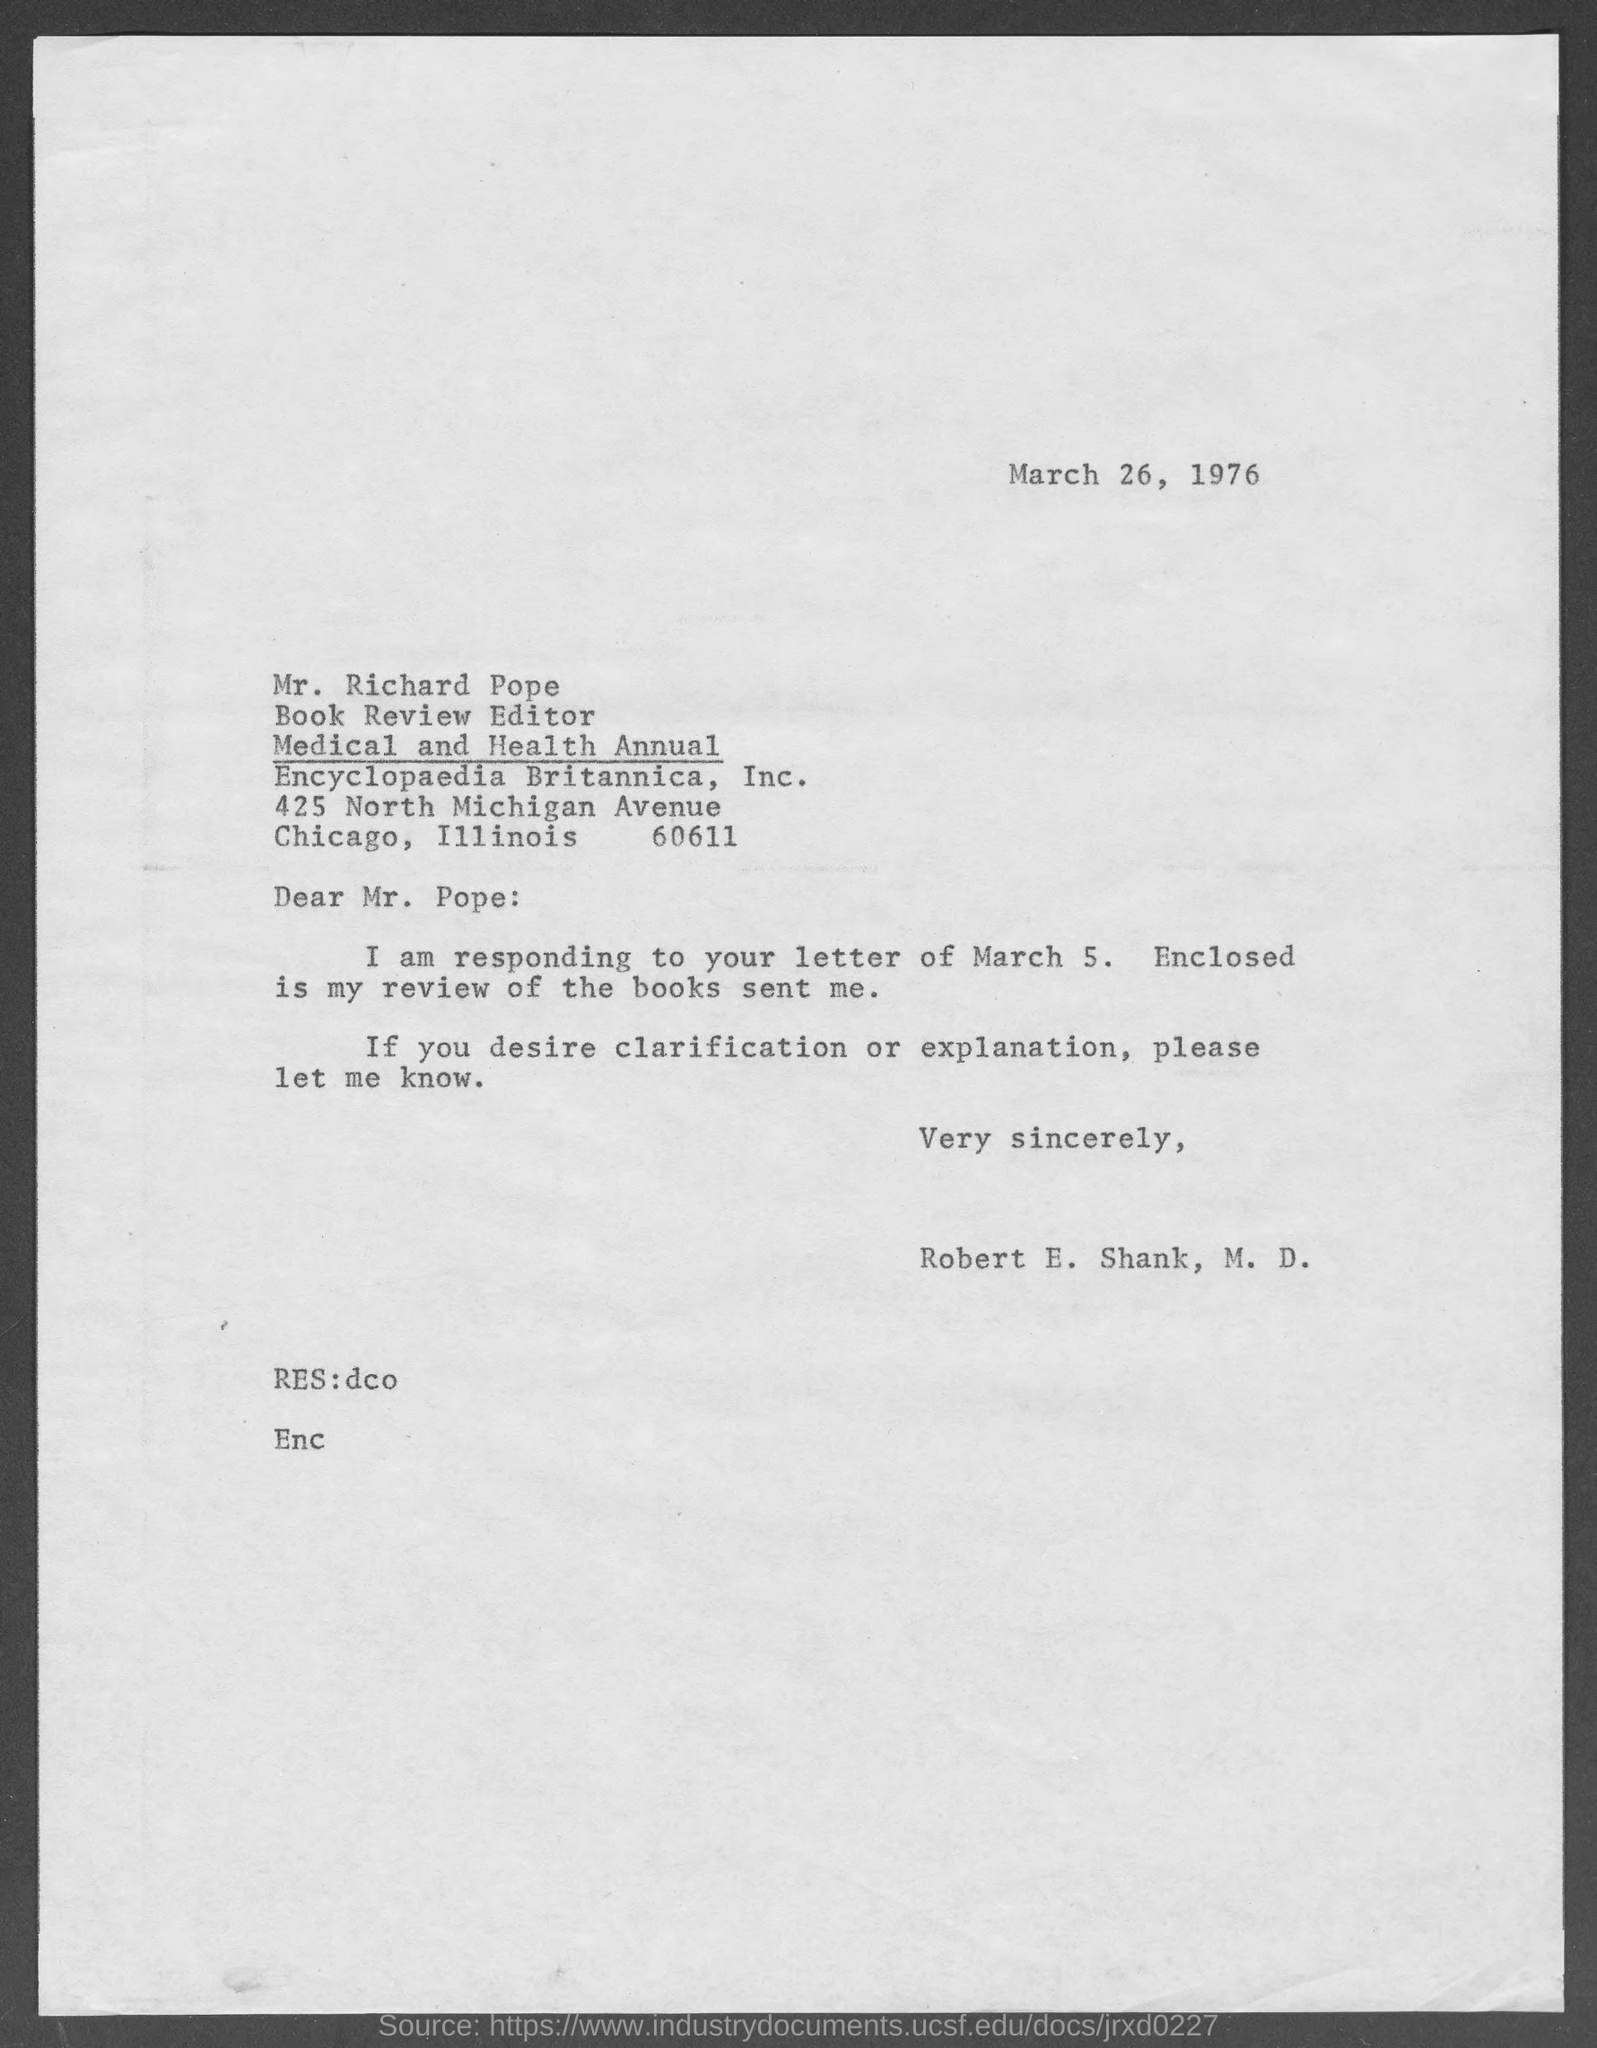Specify some key components in this picture. Mr. Richard Rope is designated as the Book Review Editor. The date mentioned is March 26, 1976. Robert E. Shank is responding to the letter dated March 5. 